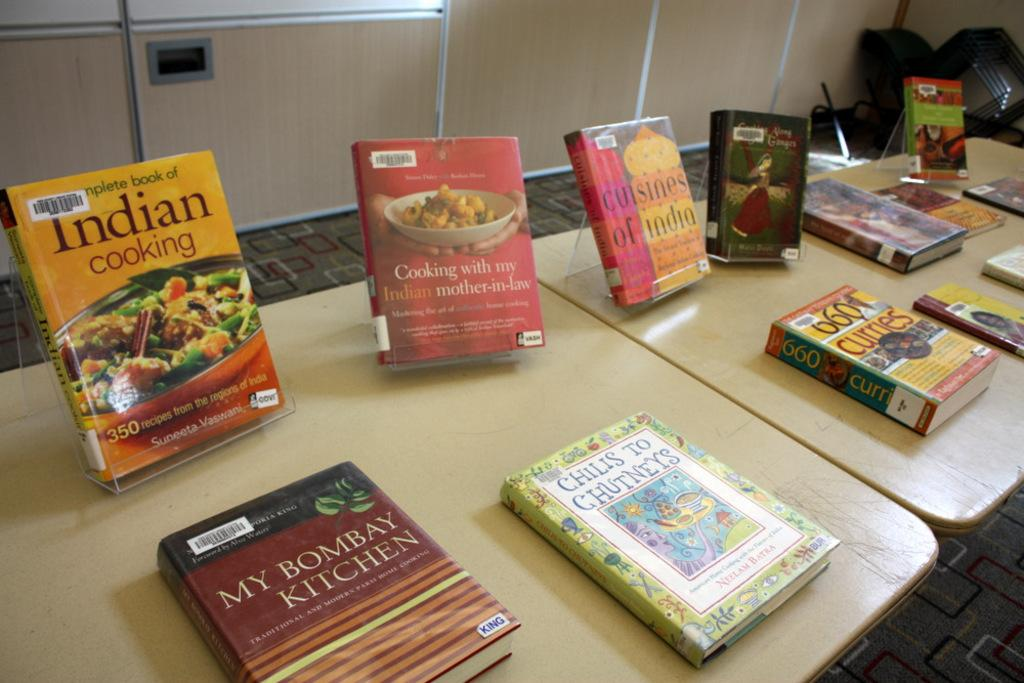<image>
Render a clear and concise summary of the photo. A variety of different indian style cook books displayed on two tables. 